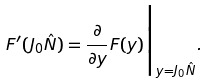<formula> <loc_0><loc_0><loc_500><loc_500>F ^ { \prime } ( J _ { 0 } \hat { N } ) = \frac { \partial } { \partial y } F ( y ) \Big | _ { y = J _ { 0 } \hat { N } } .</formula> 